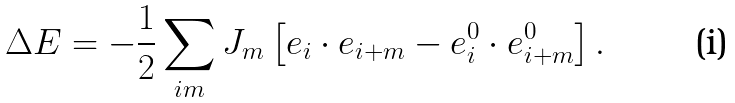Convert formula to latex. <formula><loc_0><loc_0><loc_500><loc_500>\Delta E = - \frac { 1 } { 2 } \sum _ { i m } J _ { m } \left [ { e } _ { i } \cdot { e } _ { { i } + { m } } - { e } ^ { 0 } _ { i } \cdot { e } ^ { 0 } _ { { i } + { m } } \right ] .</formula> 